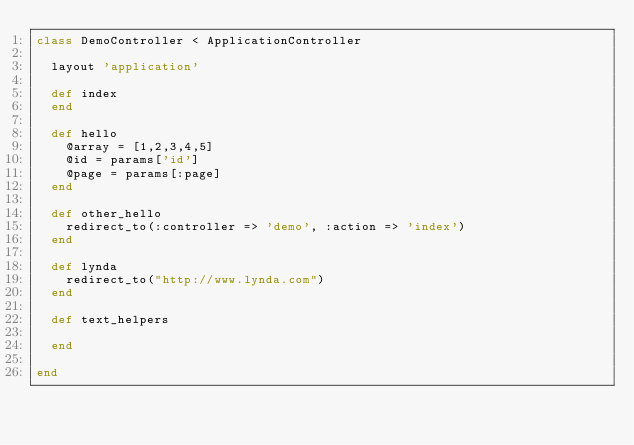<code> <loc_0><loc_0><loc_500><loc_500><_Ruby_>class DemoController < ApplicationController
  
  layout 'application'

  def index
  end

  def hello
    @array = [1,2,3,4,5]
    @id = params['id']
    @page = params[:page]
  end
  
  def other_hello
    redirect_to(:controller => 'demo', :action => 'index')
  end

  def lynda
    redirect_to("http://www.lynda.com")
  end

  def text_helpers

  end

end
</code> 